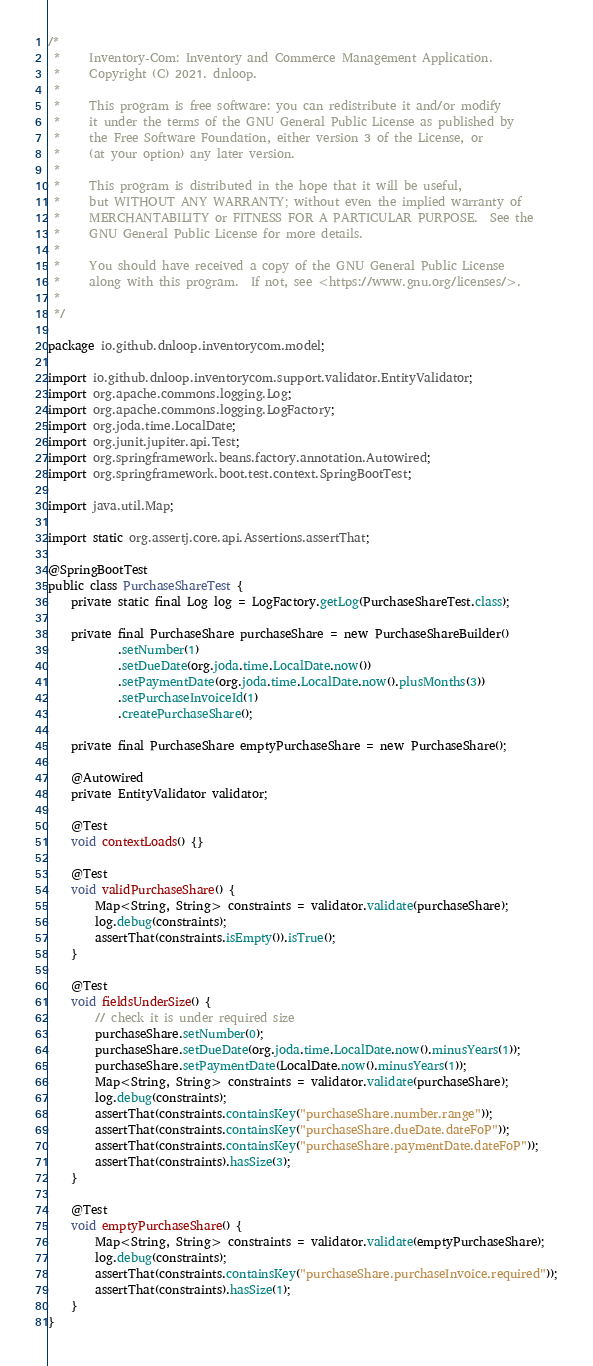Convert code to text. <code><loc_0><loc_0><loc_500><loc_500><_Java_>/*
 *     Inventory-Com: Inventory and Commerce Management Application.
 *     Copyright (C) 2021. dnloop.
 *
 *     This program is free software: you can redistribute it and/or modify
 *     it under the terms of the GNU General Public License as published by
 *     the Free Software Foundation, either version 3 of the License, or
 *     (at your option) any later version.
 *
 *     This program is distributed in the hope that it will be useful,
 *     but WITHOUT ANY WARRANTY; without even the implied warranty of
 *     MERCHANTABILITY or FITNESS FOR A PARTICULAR PURPOSE.  See the
 *     GNU General Public License for more details.
 *
 *     You should have received a copy of the GNU General Public License
 *     along with this program.  If not, see <https://www.gnu.org/licenses/>.
 *
 */

package io.github.dnloop.inventorycom.model;

import io.github.dnloop.inventorycom.support.validator.EntityValidator;
import org.apache.commons.logging.Log;
import org.apache.commons.logging.LogFactory;
import org.joda.time.LocalDate;
import org.junit.jupiter.api.Test;
import org.springframework.beans.factory.annotation.Autowired;
import org.springframework.boot.test.context.SpringBootTest;

import java.util.Map;

import static org.assertj.core.api.Assertions.assertThat;

@SpringBootTest
public class PurchaseShareTest {
    private static final Log log = LogFactory.getLog(PurchaseShareTest.class);

    private final PurchaseShare purchaseShare = new PurchaseShareBuilder()
            .setNumber(1)
            .setDueDate(org.joda.time.LocalDate.now())
            .setPaymentDate(org.joda.time.LocalDate.now().plusMonths(3))
            .setPurchaseInvoiceId(1)
            .createPurchaseShare();

    private final PurchaseShare emptyPurchaseShare = new PurchaseShare();

    @Autowired
    private EntityValidator validator;

    @Test
    void contextLoads() {}

    @Test
    void validPurchaseShare() {
        Map<String, String> constraints = validator.validate(purchaseShare);
        log.debug(constraints);
        assertThat(constraints.isEmpty()).isTrue();
    }

    @Test
    void fieldsUnderSize() {
        // check it is under required size
        purchaseShare.setNumber(0);
        purchaseShare.setDueDate(org.joda.time.LocalDate.now().minusYears(1));
        purchaseShare.setPaymentDate(LocalDate.now().minusYears(1));
        Map<String, String> constraints = validator.validate(purchaseShare);
        log.debug(constraints);
        assertThat(constraints.containsKey("purchaseShare.number.range"));
        assertThat(constraints.containsKey("purchaseShare.dueDate.dateFoP"));
        assertThat(constraints.containsKey("purchaseShare.paymentDate.dateFoP"));
        assertThat(constraints).hasSize(3);
    }

    @Test
    void emptyPurchaseShare() {
        Map<String, String> constraints = validator.validate(emptyPurchaseShare);
        log.debug(constraints);
        assertThat(constraints.containsKey("purchaseShare.purchaseInvoice.required"));
        assertThat(constraints).hasSize(1);
    }
}
</code> 